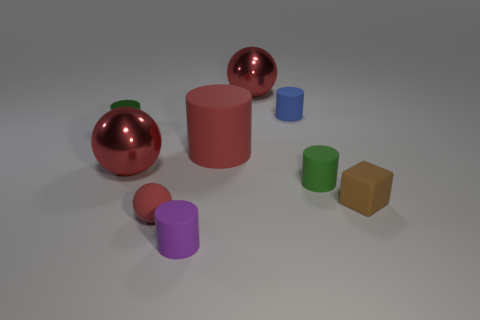Subtract all tiny blue rubber cylinders. How many cylinders are left? 4 Subtract all blue cylinders. How many cylinders are left? 4 Subtract all gray cylinders. Subtract all green blocks. How many cylinders are left? 5 Add 1 tiny brown rubber blocks. How many objects exist? 10 Subtract all balls. How many objects are left? 6 Subtract all yellow rubber cylinders. Subtract all tiny purple rubber objects. How many objects are left? 8 Add 5 tiny purple cylinders. How many tiny purple cylinders are left? 6 Add 5 big brown shiny blocks. How many big brown shiny blocks exist? 5 Subtract 0 green cubes. How many objects are left? 9 